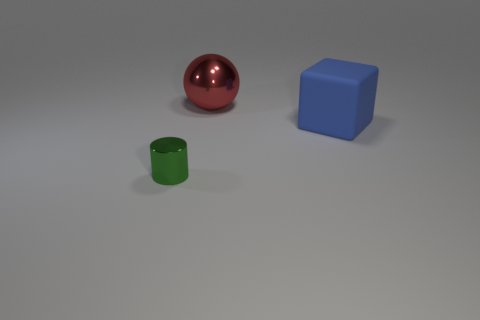Add 2 blue shiny balls. How many objects exist? 5 Subtract all cylinders. How many objects are left? 2 Add 3 tiny cylinders. How many tiny cylinders are left? 4 Add 2 tiny cylinders. How many tiny cylinders exist? 3 Subtract 0 blue cylinders. How many objects are left? 3 Subtract all red cylinders. Subtract all green blocks. How many cylinders are left? 1 Subtract all red shiny balls. Subtract all large matte blocks. How many objects are left? 1 